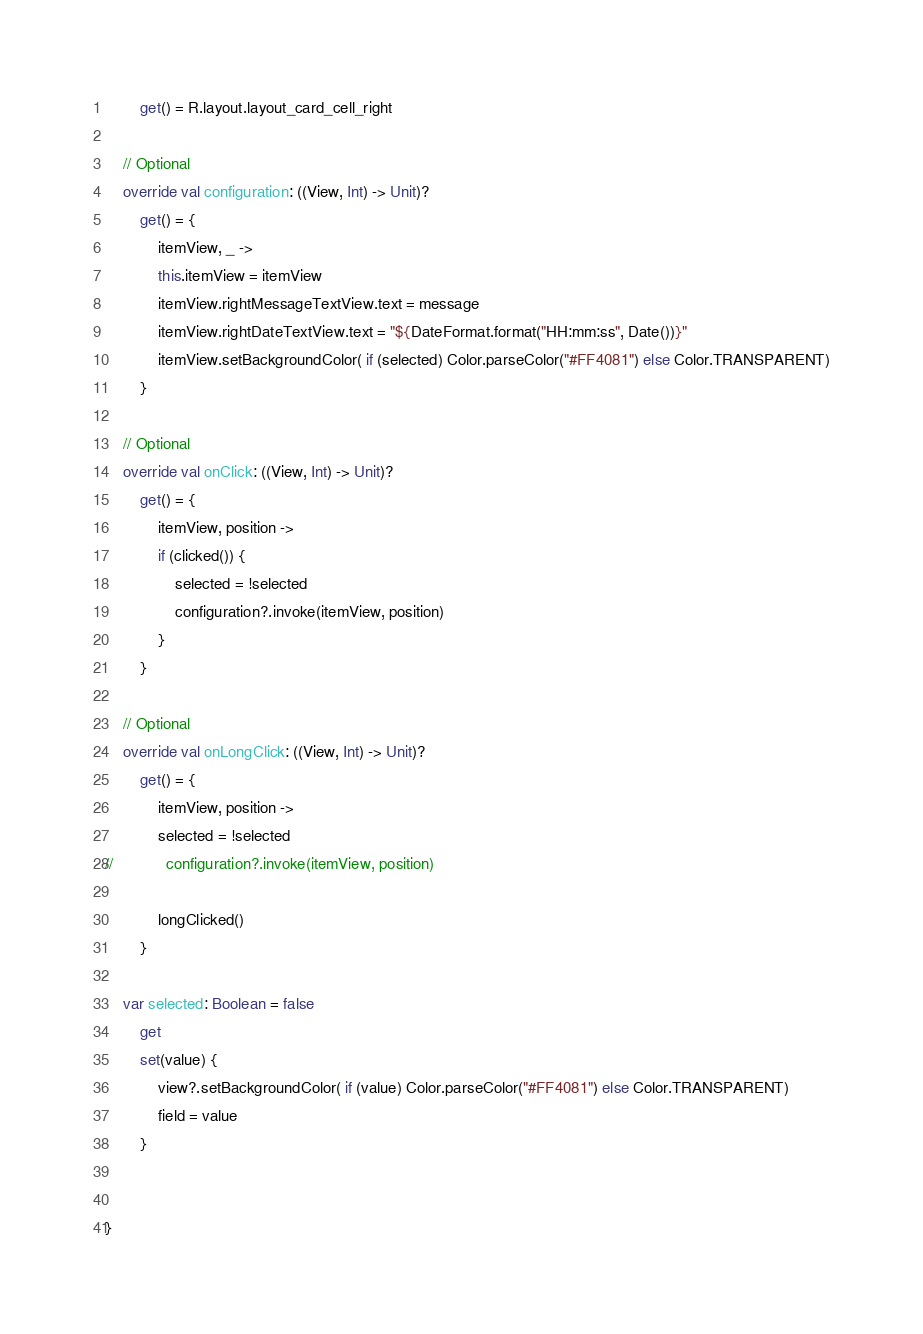<code> <loc_0><loc_0><loc_500><loc_500><_Kotlin_>        get() = R.layout.layout_card_cell_right

    // Optional
    override val configuration: ((View, Int) -> Unit)?
        get() = {
            itemView, _ ->
            this.itemView = itemView
            itemView.rightMessageTextView.text = message
            itemView.rightDateTextView.text = "${DateFormat.format("HH:mm:ss", Date())}"
            itemView.setBackgroundColor( if (selected) Color.parseColor("#FF4081") else Color.TRANSPARENT)
        }

    // Optional
    override val onClick: ((View, Int) -> Unit)?
        get() = {
            itemView, position ->
            if (clicked()) {
                selected = !selected
                configuration?.invoke(itemView, position)
            }
        }

    // Optional
    override val onLongClick: ((View, Int) -> Unit)?
        get() = {
            itemView, position ->
            selected = !selected
//            configuration?.invoke(itemView, position)

            longClicked()
        }

    var selected: Boolean = false
        get
        set(value) {
            view?.setBackgroundColor( if (value) Color.parseColor("#FF4081") else Color.TRANSPARENT)
            field = value
        }


}</code> 